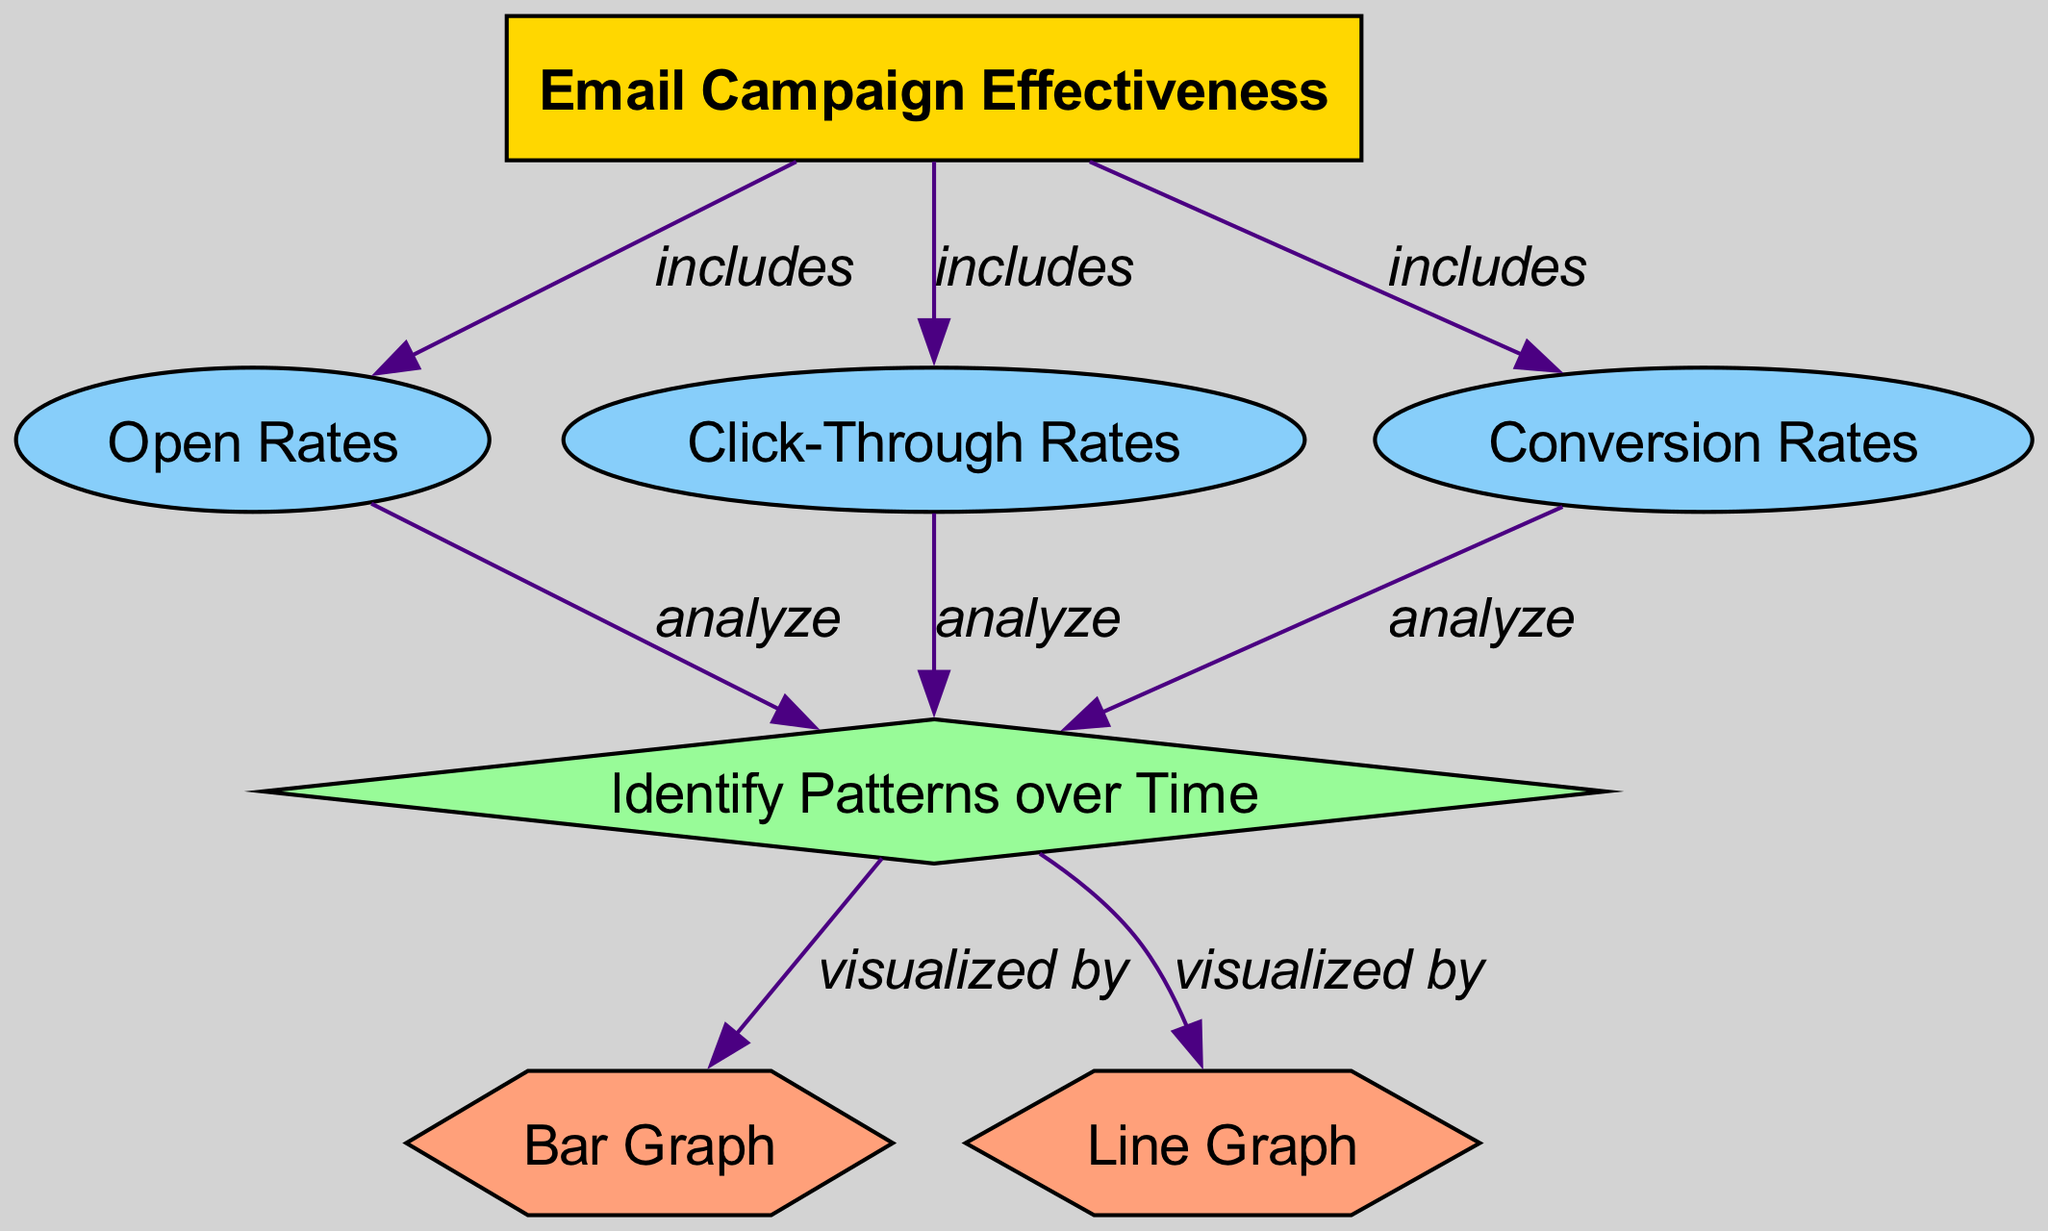What metrics are included in the email campaign effectiveness? The diagram shows three metrics under the Email Campaign Effectiveness node: Open Rates, Click-Through Rates, and Conversion Rates. These metrics are directly connected to the main node.
Answer: Open Rates, Click-Through Rates, Conversion Rates How are pattern trends analyzed? The diagram indicates that trend patterns for Open Rates, Click-Through Rates, and Conversion Rates are analyzed. Each metric node points to the Trend Patterns analysis node.
Answer: Analyzed How many types of visualizations are used in the diagram? The diagram includes two types of visualizations: Bar Graph and Line Graph, which are both connected to the Trend Patterns analysis node.
Answer: Two What type of graphs visualize trend patterns? The Trend Patterns node is visualized by two specific types of graphs: Bar Graph and Line Graph, which indicate how different metrics are represented over time.
Answer: Bar Graph and Line Graph How do Open Rates relate to Conversion Rates? Open Rates and Conversion Rates do not have a direct connection in the diagram, but both are analyzed for identifying trends, suggesting they are part of a broader analysis of effectiveness.
Answer: Not directly related Which node is the main focus of the diagram? The Email Campaign Effectiveness node is the main focus, as other elements like metrics and visualizations are derived from it, showcasing its central role in the diagram.
Answer: Email Campaign Effectiveness 